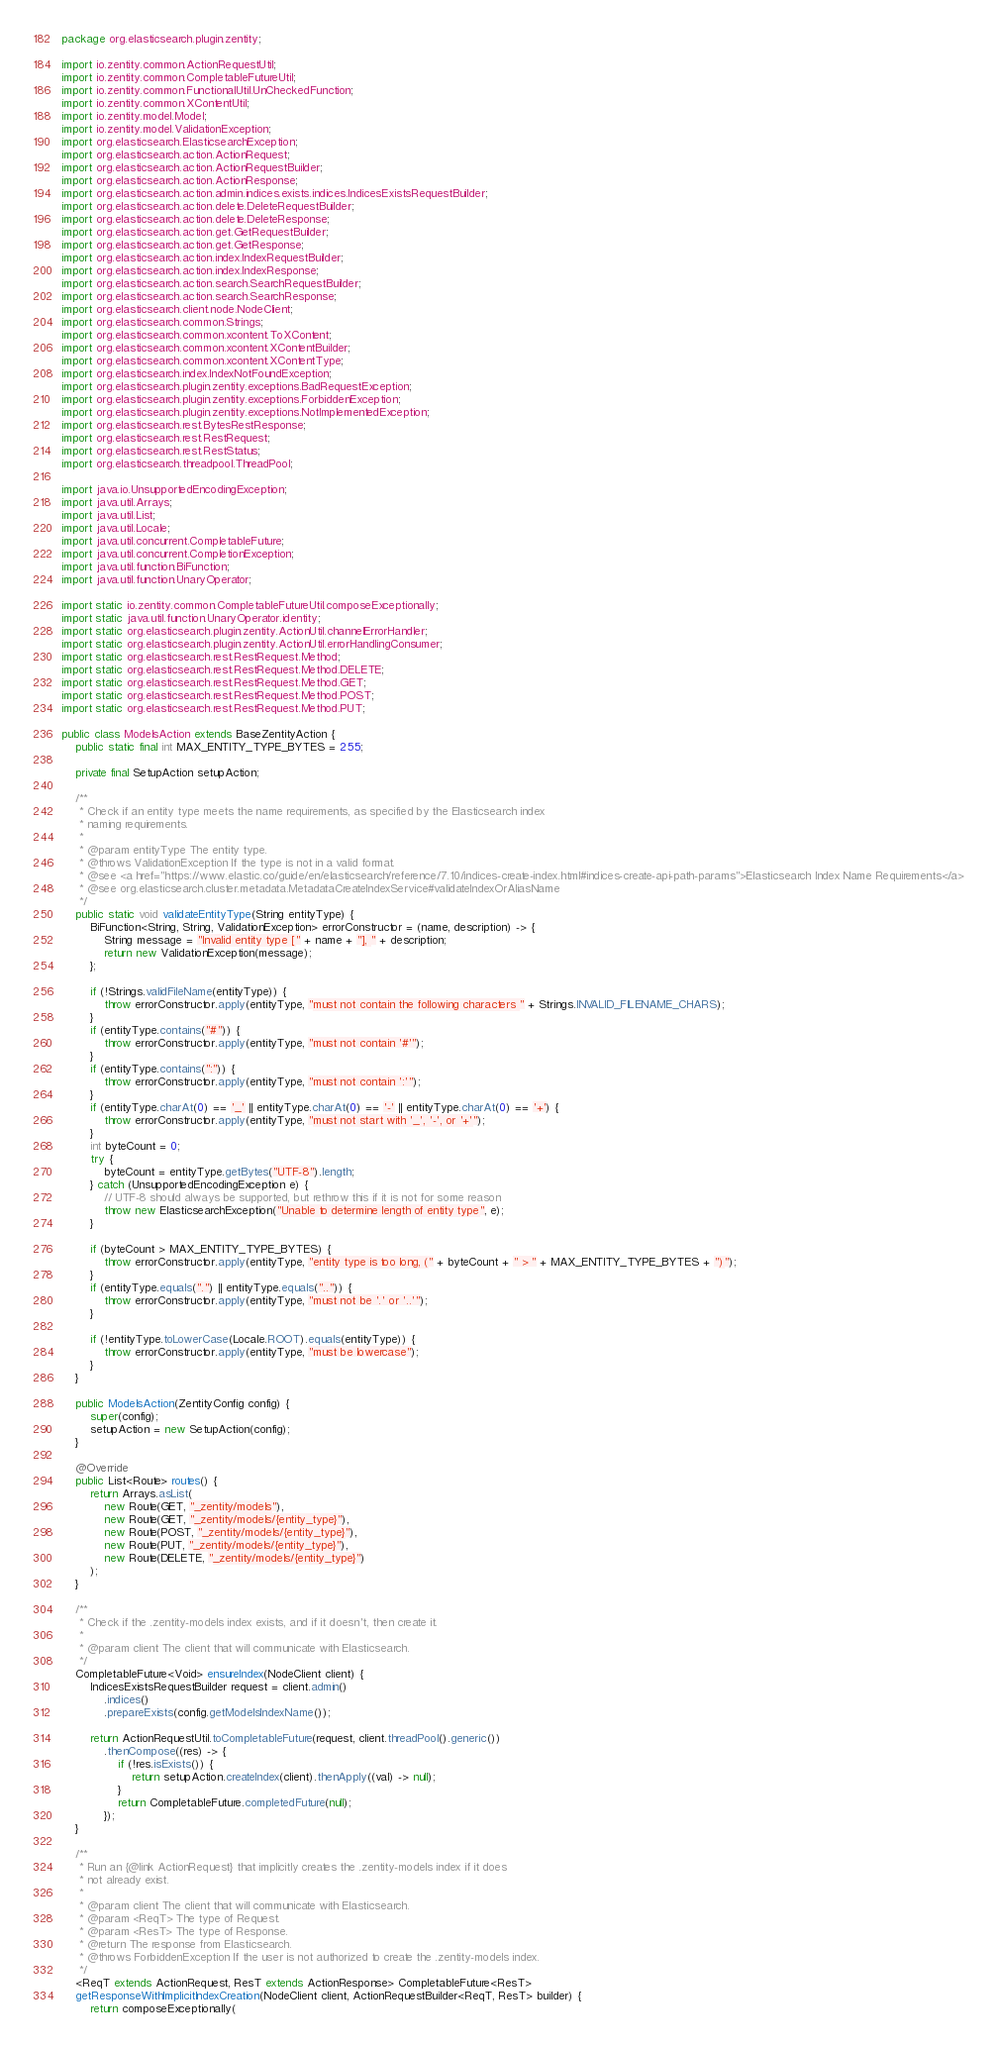Convert code to text. <code><loc_0><loc_0><loc_500><loc_500><_Java_>package org.elasticsearch.plugin.zentity;

import io.zentity.common.ActionRequestUtil;
import io.zentity.common.CompletableFutureUtil;
import io.zentity.common.FunctionalUtil.UnCheckedFunction;
import io.zentity.common.XContentUtil;
import io.zentity.model.Model;
import io.zentity.model.ValidationException;
import org.elasticsearch.ElasticsearchException;
import org.elasticsearch.action.ActionRequest;
import org.elasticsearch.action.ActionRequestBuilder;
import org.elasticsearch.action.ActionResponse;
import org.elasticsearch.action.admin.indices.exists.indices.IndicesExistsRequestBuilder;
import org.elasticsearch.action.delete.DeleteRequestBuilder;
import org.elasticsearch.action.delete.DeleteResponse;
import org.elasticsearch.action.get.GetRequestBuilder;
import org.elasticsearch.action.get.GetResponse;
import org.elasticsearch.action.index.IndexRequestBuilder;
import org.elasticsearch.action.index.IndexResponse;
import org.elasticsearch.action.search.SearchRequestBuilder;
import org.elasticsearch.action.search.SearchResponse;
import org.elasticsearch.client.node.NodeClient;
import org.elasticsearch.common.Strings;
import org.elasticsearch.common.xcontent.ToXContent;
import org.elasticsearch.common.xcontent.XContentBuilder;
import org.elasticsearch.common.xcontent.XContentType;
import org.elasticsearch.index.IndexNotFoundException;
import org.elasticsearch.plugin.zentity.exceptions.BadRequestException;
import org.elasticsearch.plugin.zentity.exceptions.ForbiddenException;
import org.elasticsearch.plugin.zentity.exceptions.NotImplementedException;
import org.elasticsearch.rest.BytesRestResponse;
import org.elasticsearch.rest.RestRequest;
import org.elasticsearch.rest.RestStatus;
import org.elasticsearch.threadpool.ThreadPool;

import java.io.UnsupportedEncodingException;
import java.util.Arrays;
import java.util.List;
import java.util.Locale;
import java.util.concurrent.CompletableFuture;
import java.util.concurrent.CompletionException;
import java.util.function.BiFunction;
import java.util.function.UnaryOperator;

import static io.zentity.common.CompletableFutureUtil.composeExceptionally;
import static java.util.function.UnaryOperator.identity;
import static org.elasticsearch.plugin.zentity.ActionUtil.channelErrorHandler;
import static org.elasticsearch.plugin.zentity.ActionUtil.errorHandlingConsumer;
import static org.elasticsearch.rest.RestRequest.Method;
import static org.elasticsearch.rest.RestRequest.Method.DELETE;
import static org.elasticsearch.rest.RestRequest.Method.GET;
import static org.elasticsearch.rest.RestRequest.Method.POST;
import static org.elasticsearch.rest.RestRequest.Method.PUT;

public class ModelsAction extends BaseZentityAction {
    public static final int MAX_ENTITY_TYPE_BYTES = 255;

    private final SetupAction setupAction;

    /**
     * Check if an entity type meets the name requirements, as specified by the Elasticsearch index
     * naming requirements.
     *
     * @param entityType The entity type.
     * @throws ValidationException If the type is not in a valid format.
     * @see <a href="https://www.elastic.co/guide/en/elasticsearch/reference/7.10/indices-create-index.html#indices-create-api-path-params">Elasticsearch Index Name Requirements</a>
     * @see org.elasticsearch.cluster.metadata.MetadataCreateIndexService#validateIndexOrAliasName
     */
    public static void validateEntityType(String entityType) {
        BiFunction<String, String, ValidationException> errorConstructor = (name, description) -> {
            String message = "Invalid entity type [" + name + "], " + description;
            return new ValidationException(message);
        };

        if (!Strings.validFileName(entityType)) {
            throw errorConstructor.apply(entityType, "must not contain the following characters " + Strings.INVALID_FILENAME_CHARS);
        }
        if (entityType.contains("#")) {
            throw errorConstructor.apply(entityType, "must not contain '#'");
        }
        if (entityType.contains(":")) {
            throw errorConstructor.apply(entityType, "must not contain ':'");
        }
        if (entityType.charAt(0) == '_' || entityType.charAt(0) == '-' || entityType.charAt(0) == '+') {
            throw errorConstructor.apply(entityType, "must not start with '_', '-', or '+'");
        }
        int byteCount = 0;
        try {
            byteCount = entityType.getBytes("UTF-8").length;
        } catch (UnsupportedEncodingException e) {
            // UTF-8 should always be supported, but rethrow this if it is not for some reason
            throw new ElasticsearchException("Unable to determine length of entity type", e);
        }

        if (byteCount > MAX_ENTITY_TYPE_BYTES) {
            throw errorConstructor.apply(entityType, "entity type is too long, (" + byteCount + " > " + MAX_ENTITY_TYPE_BYTES + ")");
        }
        if (entityType.equals(".") || entityType.equals("..")) {
            throw errorConstructor.apply(entityType, "must not be '.' or '..'");
        }

        if (!entityType.toLowerCase(Locale.ROOT).equals(entityType)) {
            throw errorConstructor.apply(entityType, "must be lowercase");
        }
    }

    public ModelsAction(ZentityConfig config) {
        super(config);
        setupAction = new SetupAction(config);
    }

    @Override
    public List<Route> routes() {
        return Arrays.asList(
            new Route(GET, "_zentity/models"),
            new Route(GET, "_zentity/models/{entity_type}"),
            new Route(POST, "_zentity/models/{entity_type}"),
            new Route(PUT, "_zentity/models/{entity_type}"),
            new Route(DELETE, "_zentity/models/{entity_type}")
        );
    }

    /**
     * Check if the .zentity-models index exists, and if it doesn't, then create it.
     *
     * @param client The client that will communicate with Elasticsearch.
     */
    CompletableFuture<Void> ensureIndex(NodeClient client) {
        IndicesExistsRequestBuilder request = client.admin()
            .indices()
            .prepareExists(config.getModelsIndexName());

        return ActionRequestUtil.toCompletableFuture(request, client.threadPool().generic())
            .thenCompose((res) -> {
                if (!res.isExists()) {
                    return setupAction.createIndex(client).thenApply((val) -> null);
                }
                return CompletableFuture.completedFuture(null);
            });
    }

    /**
     * Run an {@link ActionRequest} that implicitly creates the .zentity-models index if it does
     * not already exist.
     *
     * @param client The client that will communicate with Elasticsearch.
     * @param <ReqT> The type of Request.
     * @param <ResT> The type of Response.
     * @return The response from Elasticsearch.
     * @throws ForbiddenException If the user is not authorized to create the .zentity-models index.
     */
    <ReqT extends ActionRequest, ResT extends ActionResponse> CompletableFuture<ResT>
    getResponseWithImplicitIndexCreation(NodeClient client, ActionRequestBuilder<ReqT, ResT> builder) {
        return composeExceptionally(</code> 